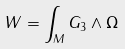<formula> <loc_0><loc_0><loc_500><loc_500>W = \int _ { M } G _ { 3 } \wedge \Omega \label l { W d e f }</formula> 